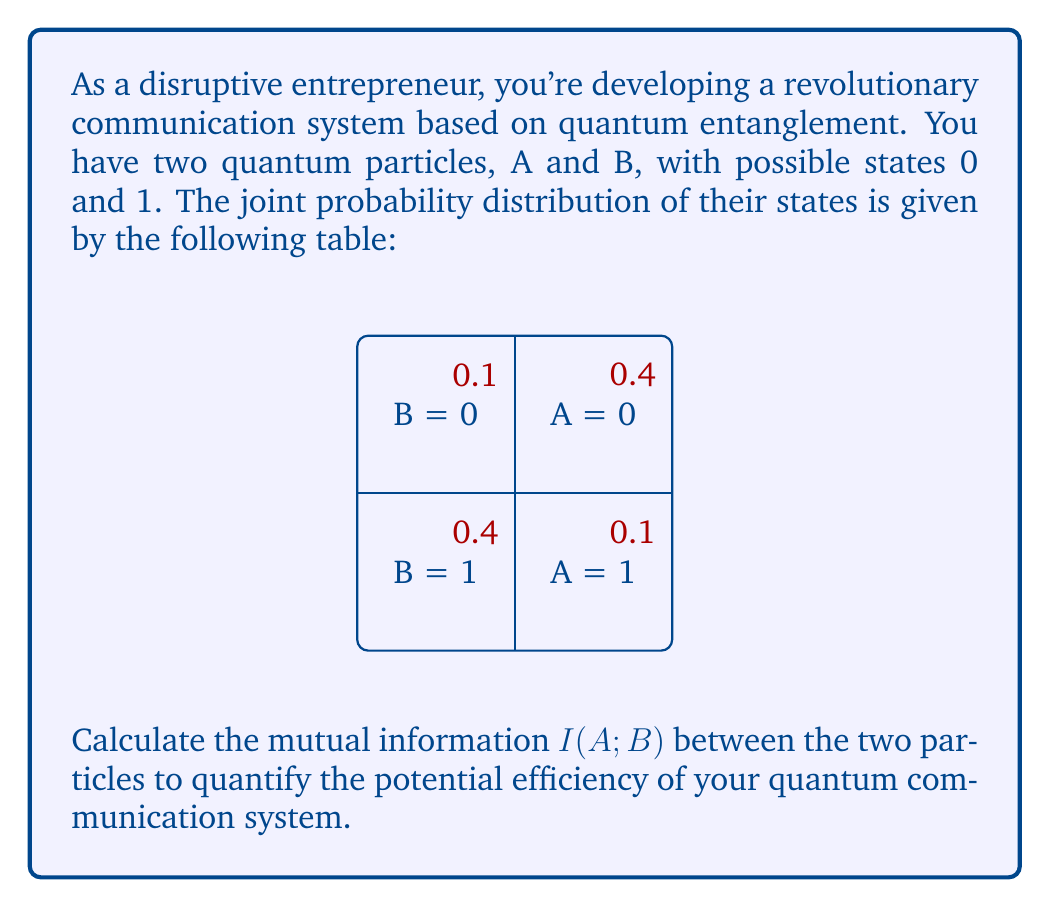Could you help me with this problem? To calculate the mutual information $I(A;B)$, we'll follow these steps:

1) First, we need to calculate the marginal probabilities:
   $P(A=0) = 0.4 + 0.1 = 0.5$
   $P(A=1) = 0.1 + 0.4 = 0.5$
   $P(B=0) = 0.4 + 0.1 = 0.5$
   $P(B=1) = 0.1 + 0.4 = 0.5$

2) The mutual information is defined as:
   $I(A;B) = \sum_{a,b} P(a,b) \log_2 \frac{P(a,b)}{P(a)P(b)}$

3) Let's calculate each term:
   For $A=0, B=0$: $0.4 \log_2 \frac{0.4}{0.5 \cdot 0.5} = 0.4 \log_2 1.6 = 0.2630$
   For $A=0, B=1$: $0.1 \log_2 \frac{0.1}{0.5 \cdot 0.5} = 0.1 \log_2 0.4 = -0.1515$
   For $A=1, B=0$: $0.1 \log_2 \frac{0.1}{0.5 \cdot 0.5} = 0.1 \log_2 0.4 = -0.1515$
   For $A=1, B=1$: $0.4 \log_2 \frac{0.4}{0.5 \cdot 0.5} = 0.4 \log_2 1.6 = 0.2630$

4) Sum all these terms:
   $I(A;B) = 0.2630 + (-0.1515) + (-0.1515) + 0.2630 = 0.2230$ bits

This value represents the amount of information shared between the two particles in your quantum communication system.
Answer: $I(A;B) = 0.2230$ bits 